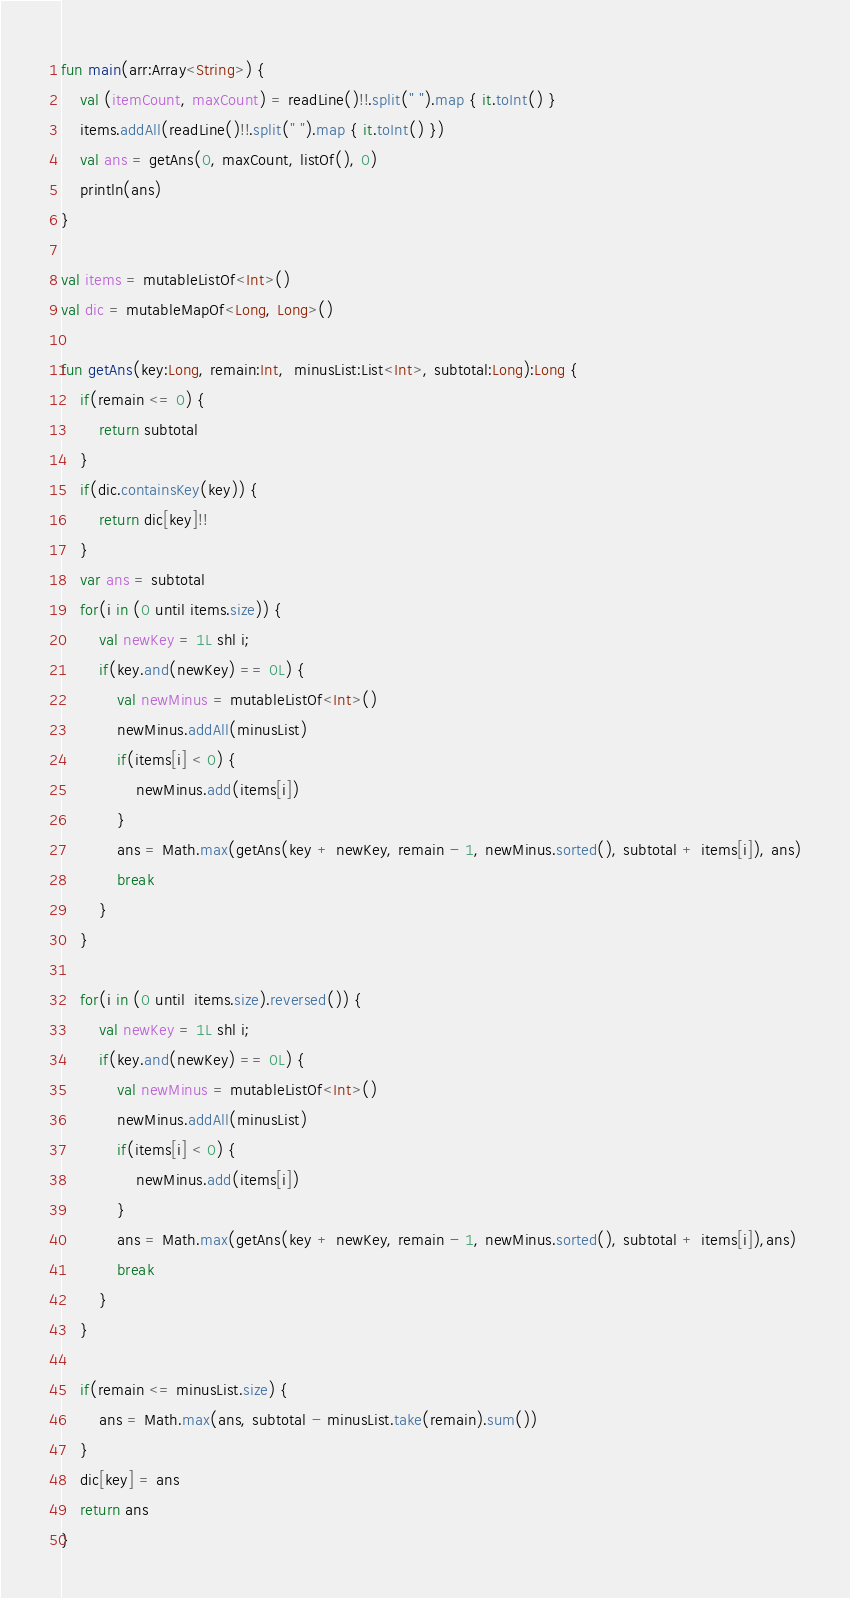<code> <loc_0><loc_0><loc_500><loc_500><_Kotlin_>

fun main(arr:Array<String>) {
    val (itemCount, maxCount) = readLine()!!.split(" ").map { it.toInt() }
    items.addAll(readLine()!!.split(" ").map { it.toInt() })
    val ans = getAns(0, maxCount, listOf(), 0)
    println(ans)
}

val items = mutableListOf<Int>()
val dic = mutableMapOf<Long, Long>()

fun getAns(key:Long, remain:Int,  minusList:List<Int>, subtotal:Long):Long {
    if(remain <= 0) {
        return subtotal
    }
    if(dic.containsKey(key)) {
        return dic[key]!!
    }
    var ans = subtotal
    for(i in (0 until items.size)) {
        val newKey = 1L shl i;
        if(key.and(newKey) == 0L) {
            val newMinus = mutableListOf<Int>()
            newMinus.addAll(minusList)
            if(items[i] < 0) {
                newMinus.add(items[i])
            }
            ans = Math.max(getAns(key + newKey, remain - 1, newMinus.sorted(), subtotal + items[i]), ans)
            break
        }
    }

    for(i in (0 until  items.size).reversed()) {
        val newKey = 1L shl i;
        if(key.and(newKey) == 0L) {
            val newMinus = mutableListOf<Int>()
            newMinus.addAll(minusList)
            if(items[i] < 0) {
                newMinus.add(items[i])
            }
            ans = Math.max(getAns(key + newKey, remain - 1, newMinus.sorted(), subtotal + items[i]),ans)
            break
        }
    }

    if(remain <= minusList.size) {
        ans = Math.max(ans, subtotal - minusList.take(remain).sum())
    }
    dic[key] = ans
    return ans
}
</code> 